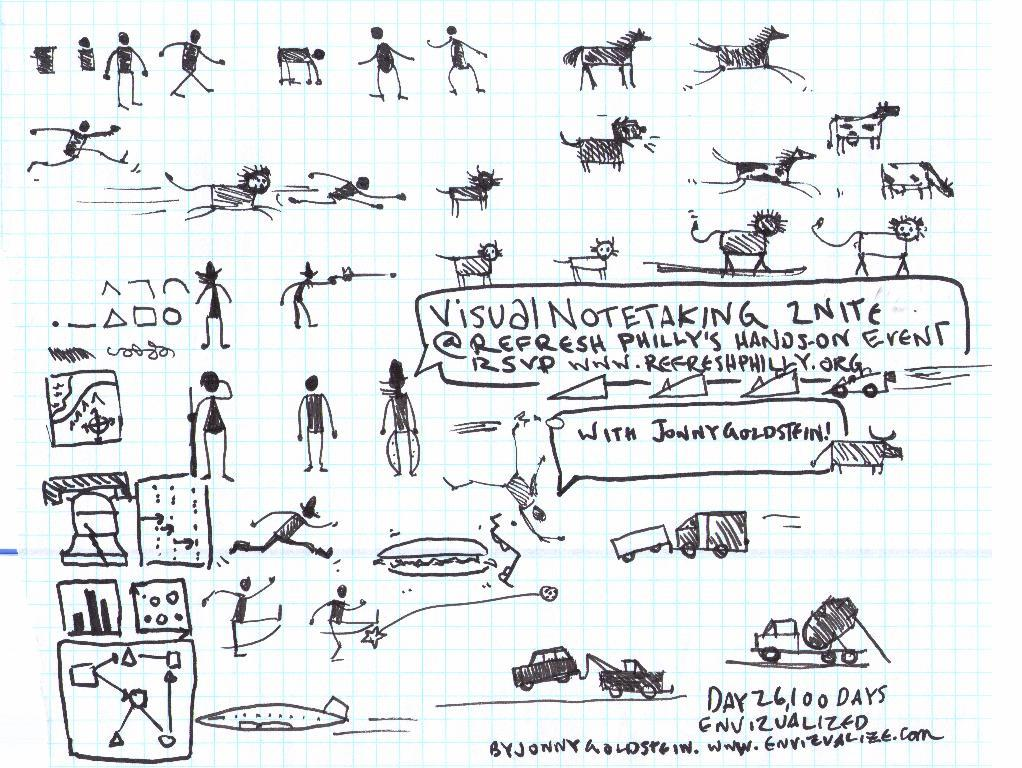What is depicted on the paper in the image? There are drawings and writing on the paper. Can you describe the drawings on the paper? Unfortunately, the specific details of the drawings cannot be determined from the provided facts. What type of writing is present on the paper? The type of writing cannot be determined from the provided facts. What type of juice is being served in the image? There is no juice present in the image; it only features drawings and writing on a paper. 